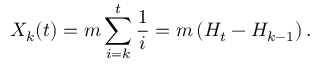Convert formula to latex. <formula><loc_0><loc_0><loc_500><loc_500>{ X } _ { k } ( t ) = m \sum _ { i = k } ^ { t } \frac { 1 } { i } = m \left ( H _ { t } - H _ { k - 1 } \right ) .</formula> 